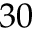Convert formula to latex. <formula><loc_0><loc_0><loc_500><loc_500>3 0</formula> 